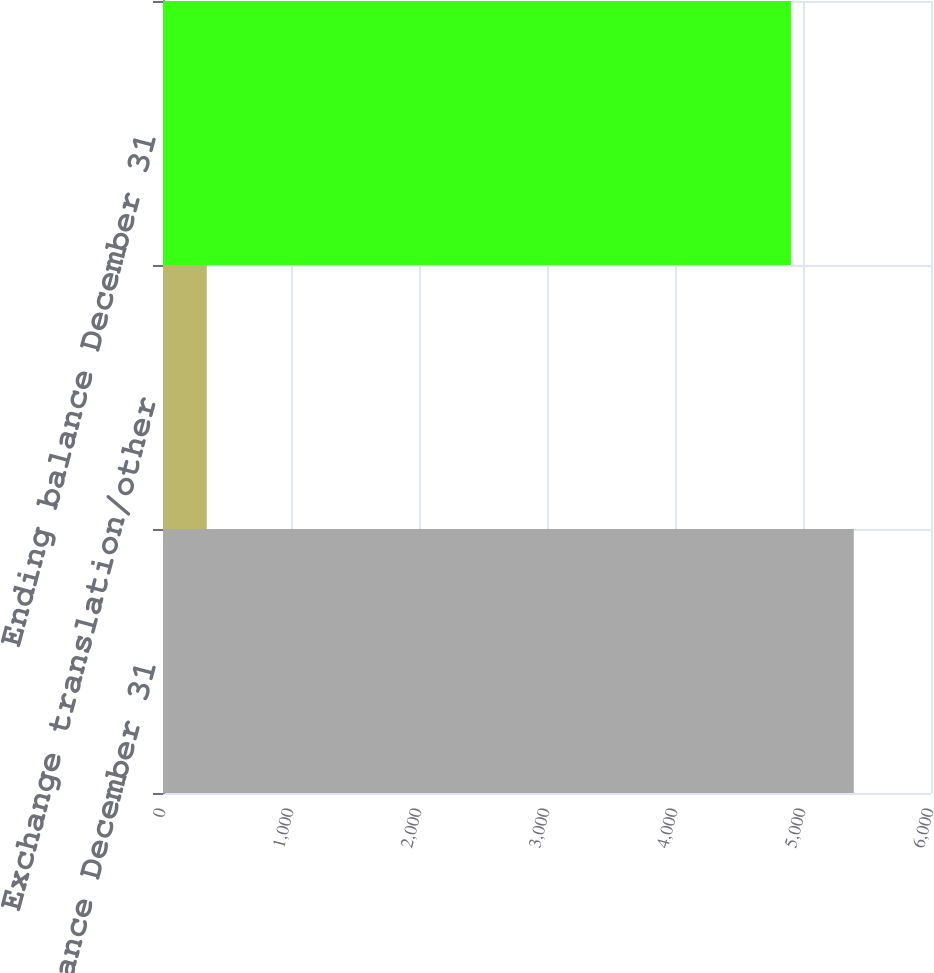Convert chart. <chart><loc_0><loc_0><loc_500><loc_500><bar_chart><fcel>Beginning balance December 31<fcel>Exchange translation/other<fcel>Ending balance December 31<nl><fcel>5396.6<fcel>342<fcel>4906<nl></chart> 